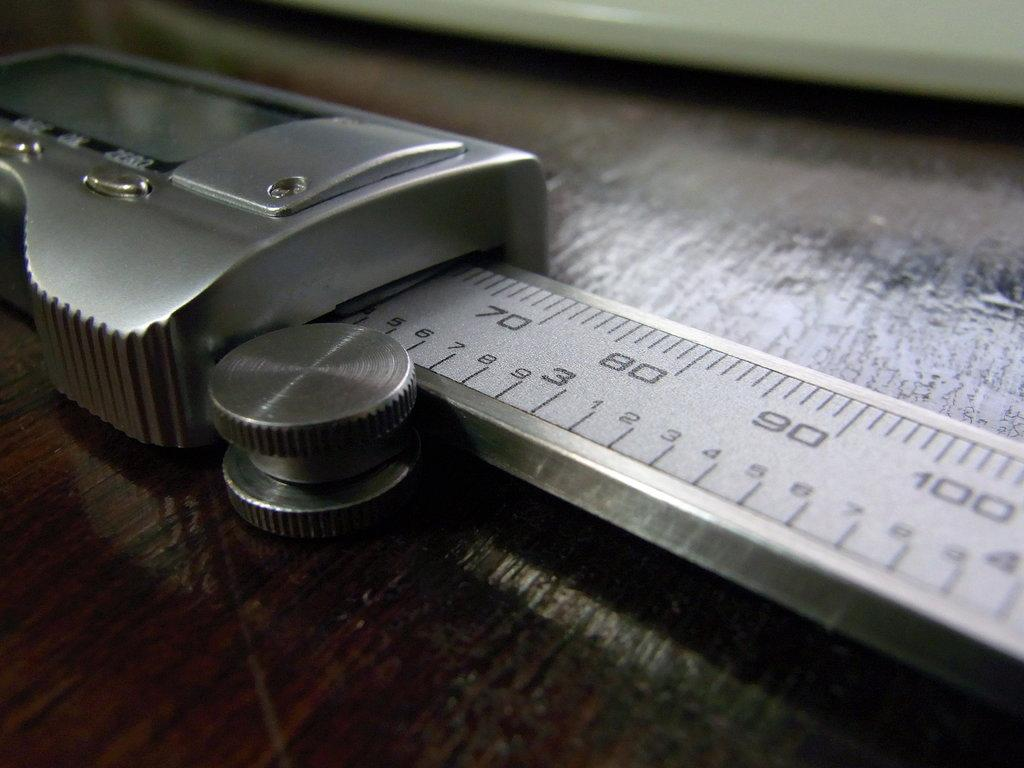<image>
Share a concise interpretation of the image provided. An electronic ruler or caliper showing from 65 to 100. 